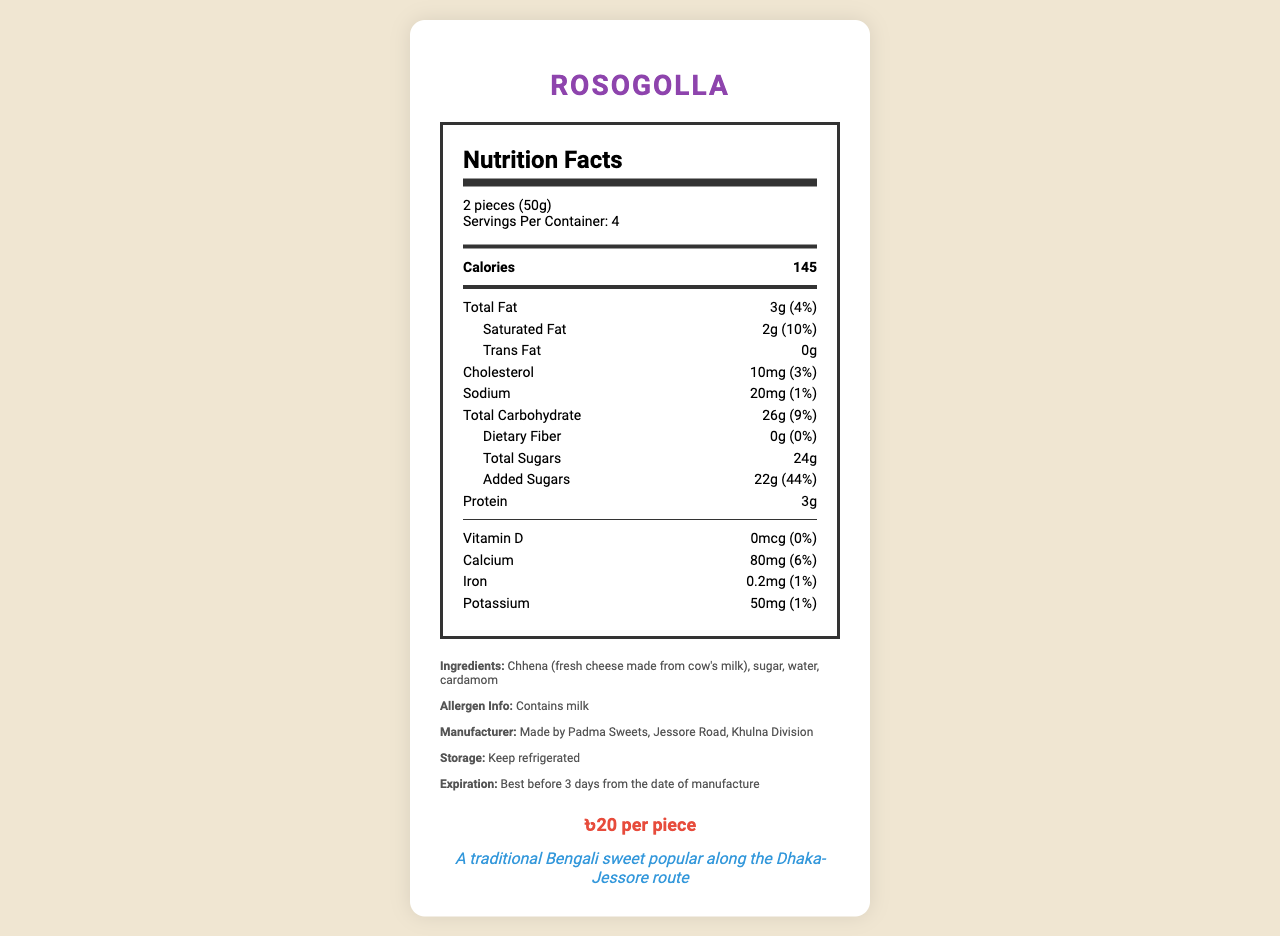what is the serving size? The serving size is clearly mentioned at the beginning of the nutrition label under the serving information.
Answer: 2 pieces (50g) how many servings are in the container? The document states "Servings Per Container: 4" under the serving size information.
Answer: 4 how many calories are in one serving of Rosogolla? The calorie count per serving is displayed prominently right below the serving information.
Answer: 145 what is the total fat content per serving? The total fat amount per serving is listed as 3g with a percent daily value of 4%.
Answer: 3g what percentage of the daily value is the saturated fat per serving? The saturated fat section shows it's 2g, which is 10% of the daily value.
Answer: 10% how much added sugar is in one serving? The nutrition label lists the added sugars separately as 22g with a 44% daily value.
Answer: 22g what is the primary ingredient in Rosogolla? The ingredients list starts with Chhena, indicating it is the primary ingredient.
Answer: Chhena (fresh cheese made from cow's milk) what is the price per piece of Rosogolla? The price information at the bottom states the cost per piece of Rosogolla.
Answer: ৳20 per piece what is the daily value percent of cholesterol in one serving? The cholesterol amount is listed at 10mg, constituting 3% of the daily value.
Answer: 3% how long can Rosogolla be stored? The storage instructions say the item is best before 3 days from the manufacturing date.
Answer: Best before 3 days from the date of manufacture what is the sodium content per serving? A. 10mg B. 20mg C. 30mg D. 40mg The sodium content is 20mg, listed with 1% of the daily value next to it.
Answer: B what type of milk product is used in Rosogolla? A. Chhena B. Condensed Milk C. Yogurt The ingredients list specifies Chhena (fresh cheese made from cow's milk) as the milk product used.
Answer: A is there any dietary fiber in Rosogolla? The nutrition label specifies 0g of dietary fiber with a 0% daily value.
Answer: No does Rosogolla contain any allergens? The allergen information mentioned in the document states it contains milk.
Answer: Yes summarize the main nutritional content of Rosogolla. The document provides detailed nutritional facts, ingredients, allergen, and storage information, along with manufacturing details and pricing for Rosogolla.
Answer: Rosogolla is a traditional Bengali sweet with 145 calories per serving, minimal fat, substantial added sugars, and some protein and calcium. It is made primarily from Chhena, contains allergens, and should be stored refrigerated and consumed within 3 days. what is the amount of potassium per serving? The nutrition label clearly lists the potassium content as 50mg with a 1% daily value.
Answer: 50mg how much protein is in each serving? The nutrition label indicates that each serving contains 3g of protein.
Answer: 3g how many calories would be consumed if someone ate the entire container? Since each serving contains 145 calories and there are 4 servings per container, the total calories would be 145 x 4 = 580.
Answer: 580 who is the manufacturer of Rosogolla? The manufacturer's information is listed in the extra information section of the document.
Answer: Padma Sweets, Jessore Road, Khulna Division what is the vitamin D content per serving? The vitamin D content is listed as 0mcg with a 0% daily value.
Answer: 0mcg what is the expiration date after purchasing Rosogolla? The expiration date provided is relative to the date of manufacture, which isn't specified in the provided visual information.
Answer: Cannot be determined 